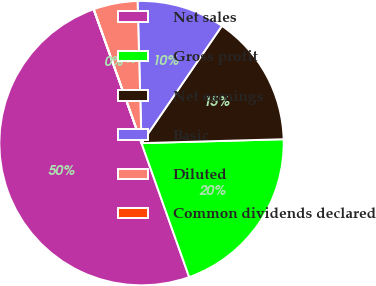Convert chart. <chart><loc_0><loc_0><loc_500><loc_500><pie_chart><fcel>Net sales<fcel>Gross profit<fcel>Net earnings<fcel>Basic<fcel>Diluted<fcel>Common dividends declared<nl><fcel>49.97%<fcel>20.0%<fcel>15.0%<fcel>10.01%<fcel>5.01%<fcel>0.02%<nl></chart> 